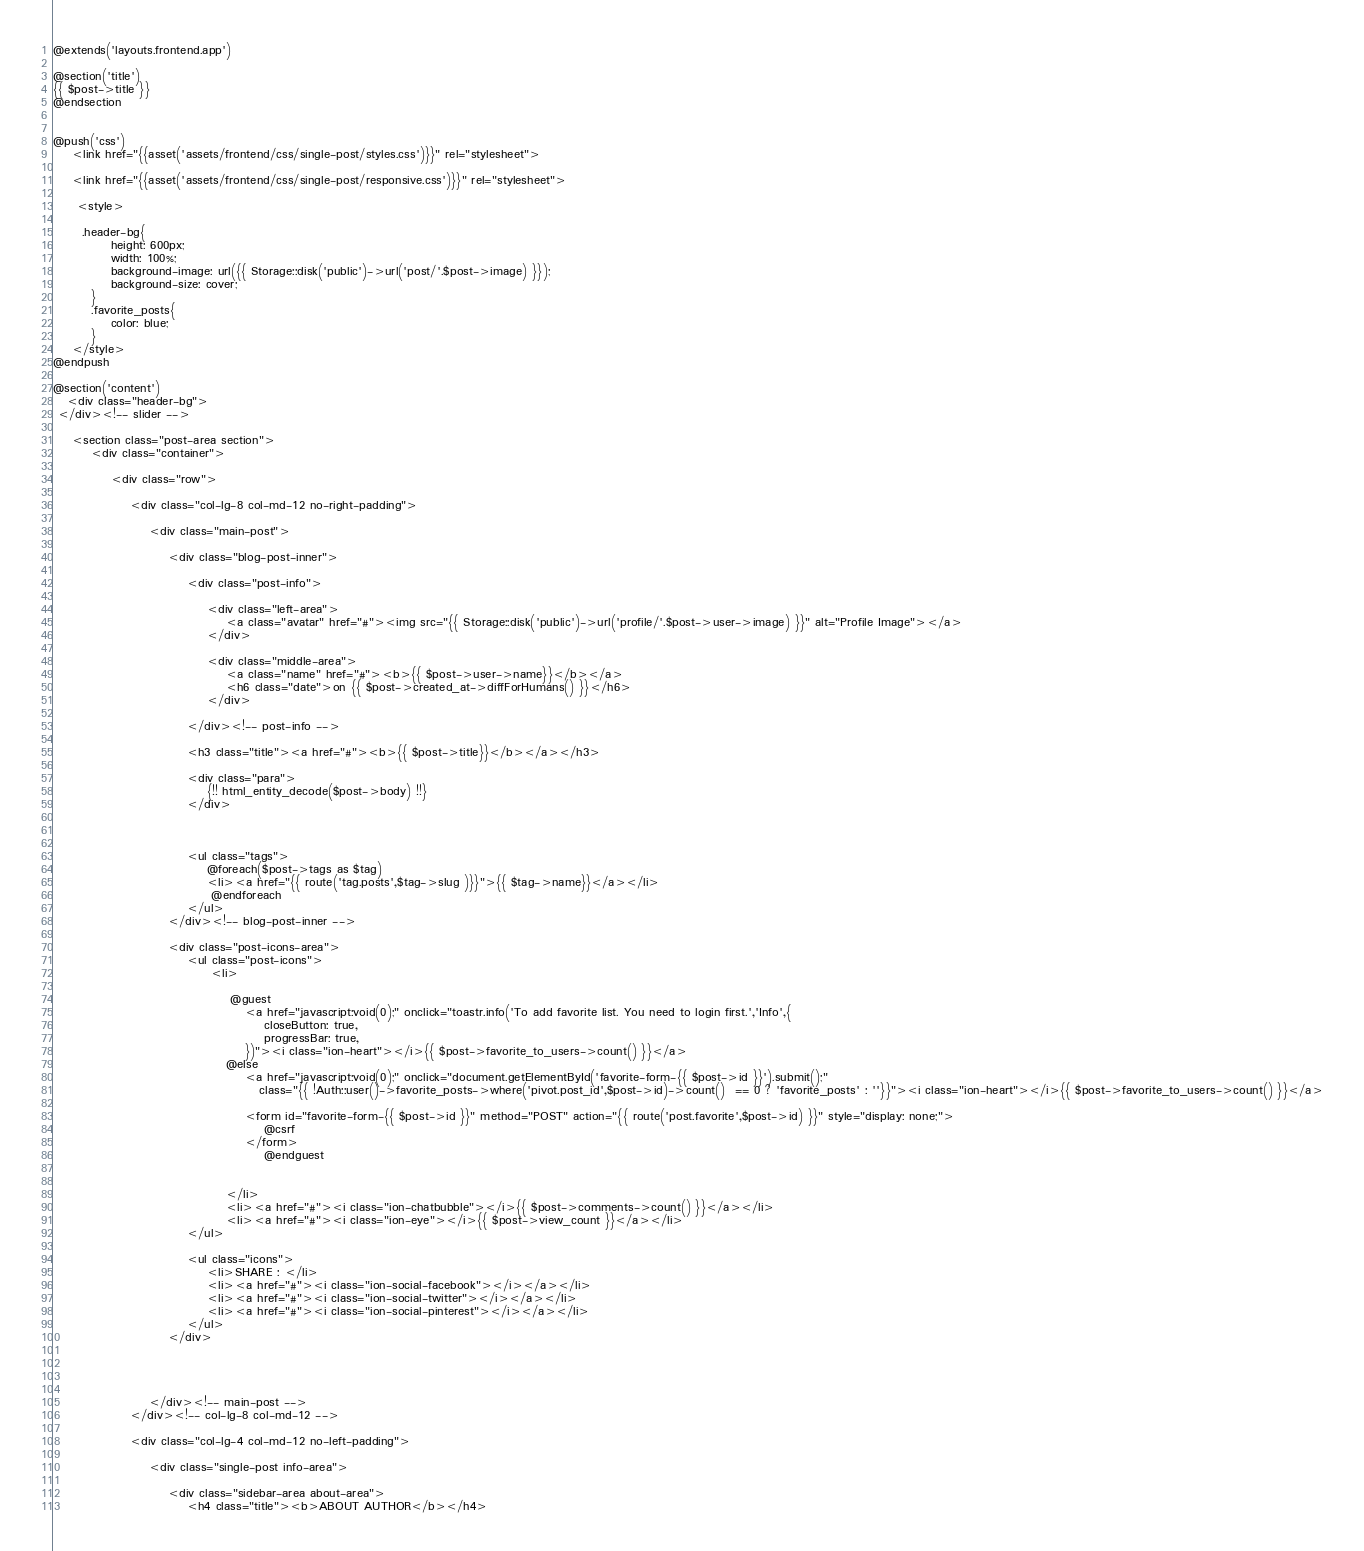<code> <loc_0><loc_0><loc_500><loc_500><_PHP_>@extends('layouts.frontend.app')

@section('title')
{{ $post->title }}
@endsection


@push('css')
    <link href="{{asset('assets/frontend/css/single-post/styles.css')}}" rel="stylesheet">

    <link href="{{asset('assets/frontend/css/single-post/responsive.css')}}" rel="stylesheet">

     <style>

      .header-bg{
            height: 600px;
            width: 100%;
            background-image: url({{ Storage::disk('public')->url('post/'.$post->image) }});
            background-size: cover;
        }
        .favorite_posts{
            color: blue;
        }
    </style>
@endpush

@section('content')
   <div class="header-bg">
 </div><!-- slider -->

	<section class="post-area section">
		<div class="container">

			<div class="row">

				<div class="col-lg-8 col-md-12 no-right-padding">

					<div class="main-post">

						<div class="blog-post-inner">

							<div class="post-info">

								<div class="left-area">
									<a class="avatar" href="#"><img src="{{ Storage::disk('public')->url('profile/'.$post->user->image) }}" alt="Profile Image"></a>
								</div>

								<div class="middle-area">
									<a class="name" href="#"><b>{{ $post->user->name}}</b></a>
									<h6 class="date">on {{ $post->created_at->diffForHumans() }}</h6>
								</div>

							</div><!-- post-info -->

							<h3 class="title"><a href="#"><b>{{ $post->title}}</b></a></h3>

							<div class="para">
								{!! html_entity_decode($post->body) !!}
							</div>

						

							<ul class="tags">
								@foreach($post->tags as $tag)
								<li><a href="{{ route('tag.posts',$tag->slug )}}">{{ $tag->name}}</a></li>
                                 @endforeach
							</ul>
						</div><!-- blog-post-inner -->

						<div class="post-icons-area">
							<ul class="post-icons">
								 <li>

                                     @guest
                                        <a href="javascript:void(0);" onclick="toastr.info('To add favorite list. You need to login first.','Info',{
                                            closeButton: true,
                                            progressBar: true,
                                        })"><i class="ion-heart"></i>{{ $post->favorite_to_users->count() }}</a>
                                    @else
                                        <a href="javascript:void(0);" onclick="document.getElementById('favorite-form-{{ $post->id }}').submit();"
                                           class="{{ !Auth::user()->favorite_posts->where('pivot.post_id',$post->id)->count()  == 0 ? 'favorite_posts' : ''}}"><i class="ion-heart"></i>{{ $post->favorite_to_users->count() }}</a>

                                        <form id="favorite-form-{{ $post->id }}" method="POST" action="{{ route('post.favorite',$post->id) }}" style="display: none;">
                                            @csrf
                                        </form>
                                            @endguest


                                    </li>
                                    <li><a href="#"><i class="ion-chatbubble"></i>{{ $post->comments->count() }}</a></li>
                                    <li><a href="#"><i class="ion-eye"></i>{{ $post->view_count }}</a></li>
							</ul>

							<ul class="icons">
								<li>SHARE : </li>
								<li><a href="#"><i class="ion-social-facebook"></i></a></li>
								<li><a href="#"><i class="ion-social-twitter"></i></a></li>
								<li><a href="#"><i class="ion-social-pinterest"></i></a></li>
							</ul>
						</div>

						


					</div><!-- main-post -->
				</div><!-- col-lg-8 col-md-12 -->

				<div class="col-lg-4 col-md-12 no-left-padding">

					<div class="single-post info-area">

						<div class="sidebar-area about-area">
							<h4 class="title"><b>ABOUT AUTHOR</b></h4></code> 